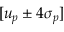Convert formula to latex. <formula><loc_0><loc_0><loc_500><loc_500>[ u _ { p } \pm 4 \sigma _ { p } ]</formula> 